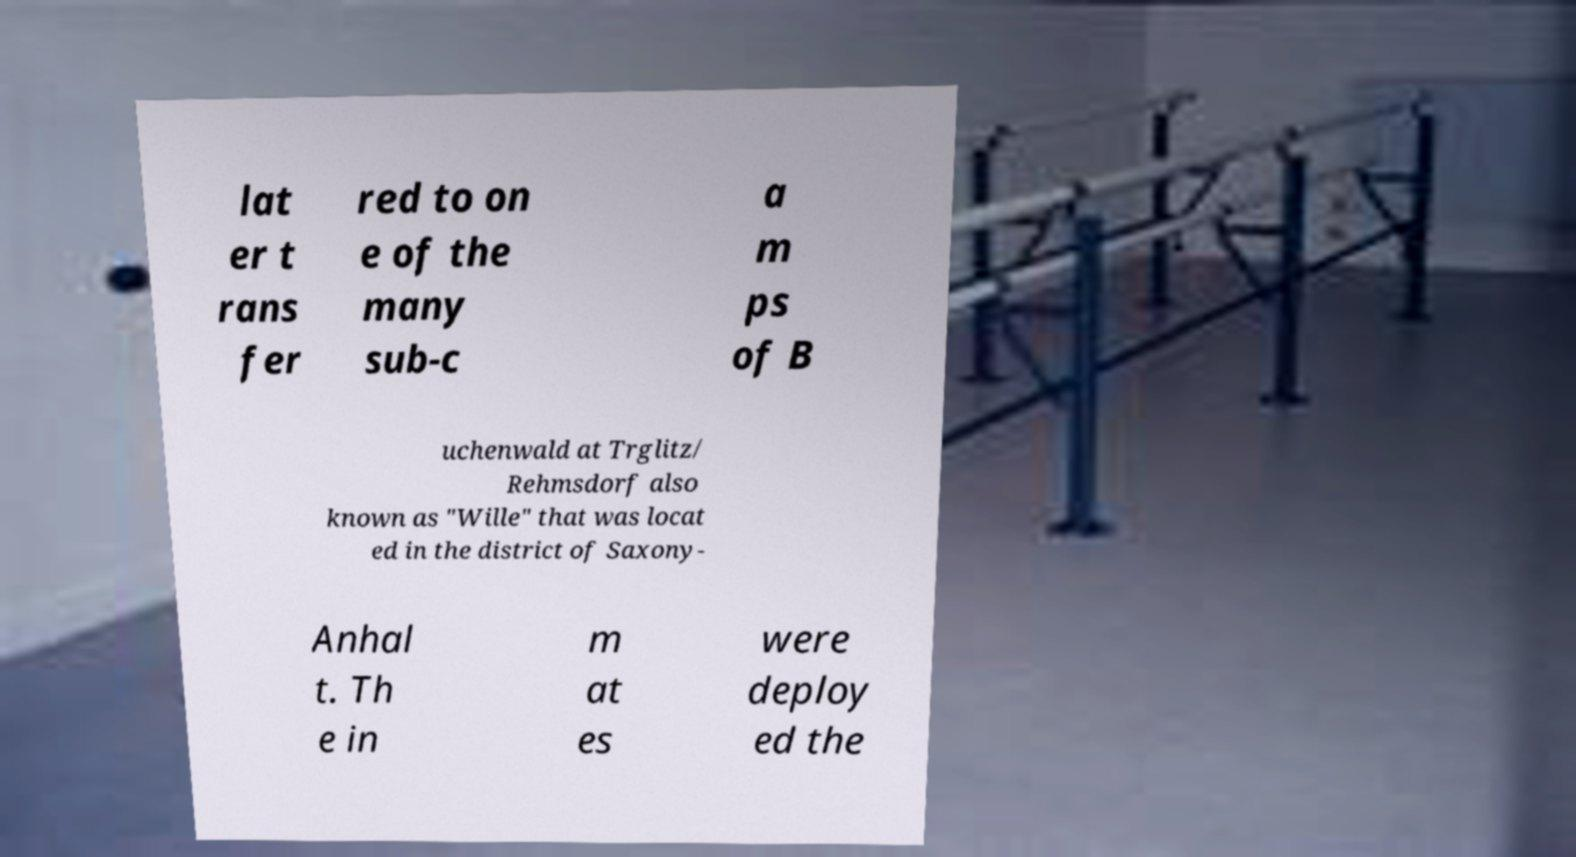What messages or text are displayed in this image? I need them in a readable, typed format. lat er t rans fer red to on e of the many sub-c a m ps of B uchenwald at Trglitz/ Rehmsdorf also known as "Wille" that was locat ed in the district of Saxony- Anhal t. Th e in m at es were deploy ed the 